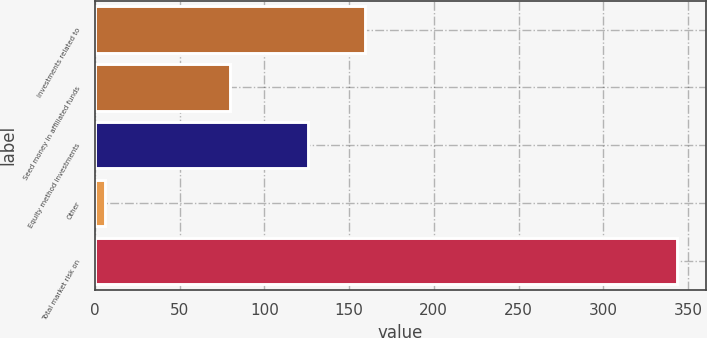<chart> <loc_0><loc_0><loc_500><loc_500><bar_chart><fcel>Investments related to<fcel>Seed money in affiliated funds<fcel>Equity method investments<fcel>Other<fcel>Total market risk on<nl><fcel>159.25<fcel>79.6<fcel>125.5<fcel>6<fcel>343.5<nl></chart> 